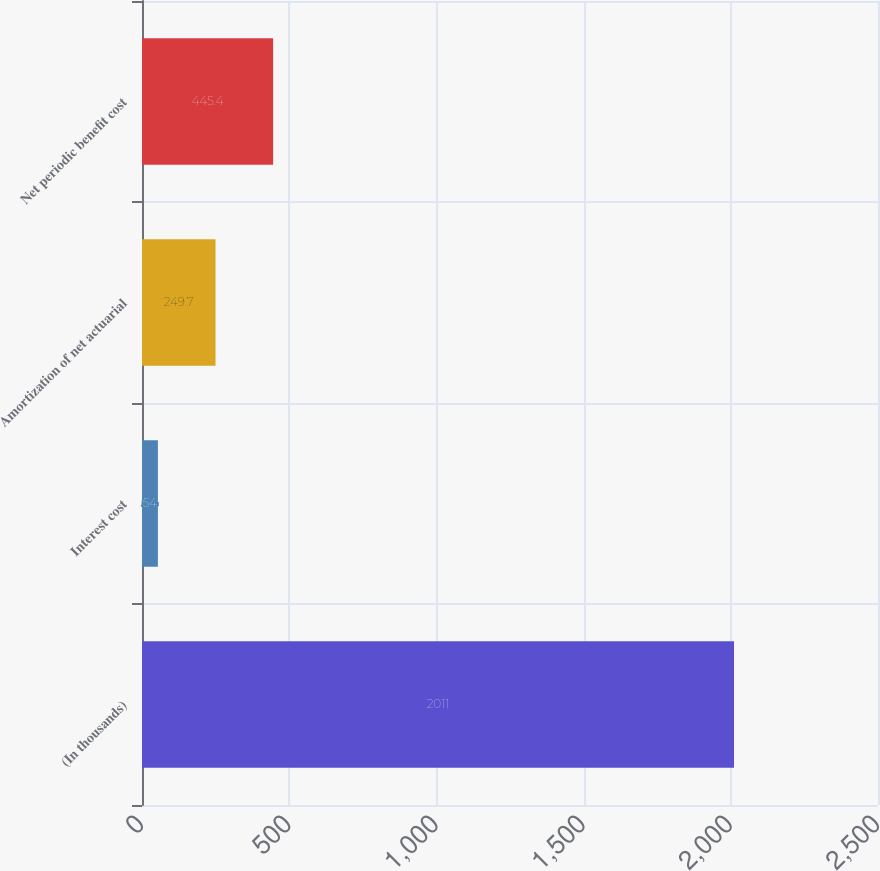Convert chart to OTSL. <chart><loc_0><loc_0><loc_500><loc_500><bar_chart><fcel>(In thousands)<fcel>Interest cost<fcel>Amortization of net actuarial<fcel>Net periodic benefit cost<nl><fcel>2011<fcel>54<fcel>249.7<fcel>445.4<nl></chart> 